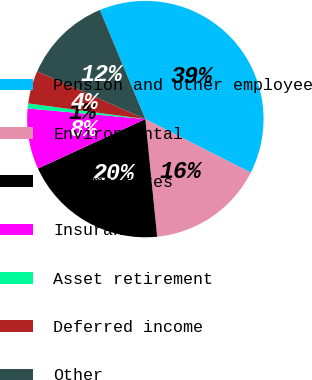Convert chart to OTSL. <chart><loc_0><loc_0><loc_500><loc_500><pie_chart><fcel>Pension and other employee<fcel>Environmental<fcel>Income taxes<fcel>Insurance<fcel>Asset retirement<fcel>Deferred income<fcel>Other<nl><fcel>38.77%<fcel>15.92%<fcel>19.73%<fcel>8.3%<fcel>0.68%<fcel>4.49%<fcel>12.11%<nl></chart> 